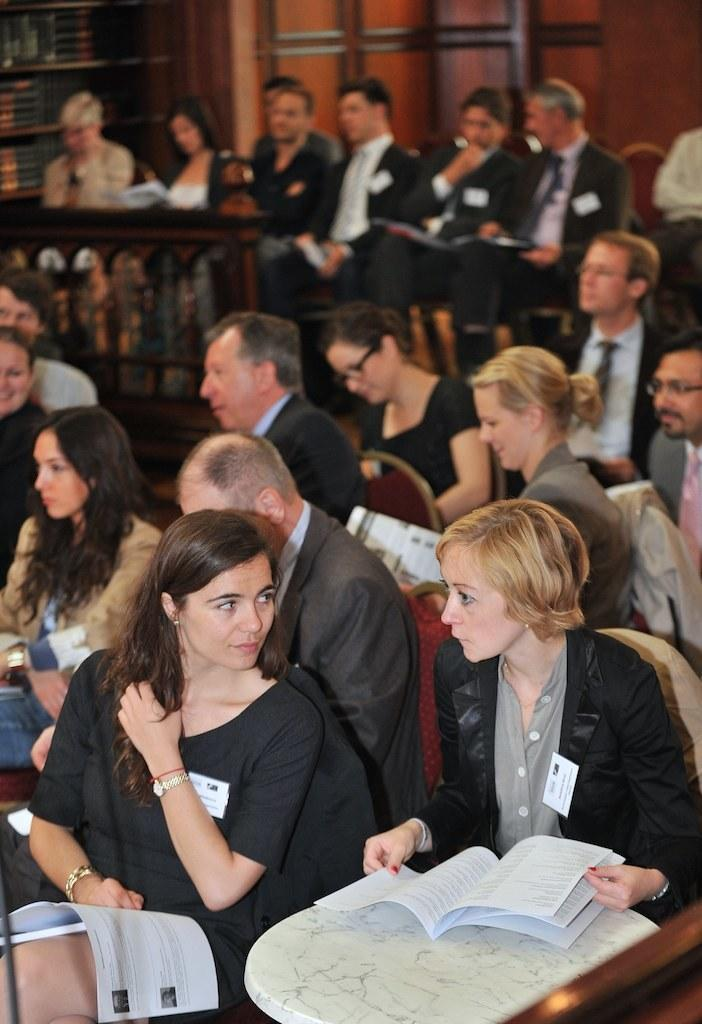What are the people in the image doing? There are people sitting in the chairs in the image. Can you describe the gender of the people in the image? There are both men and women in the image. What are most of the people holding in the image? Most of the people are holding papers in the image. How would you describe the background of the image? The background is partially blurred in the image. What type of leaf can be seen falling in the image? There is no leaf present in the image; it does not depict any falling leaves. 